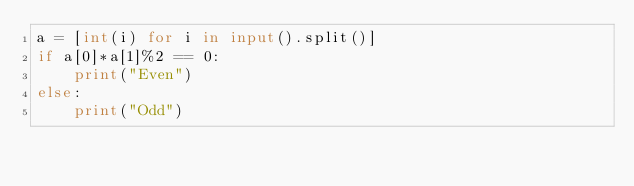Convert code to text. <code><loc_0><loc_0><loc_500><loc_500><_Python_>a = [int(i) for i in input().split()]
if a[0]*a[1]%2 == 0:
    print("Even")
else:
    print("Odd")</code> 